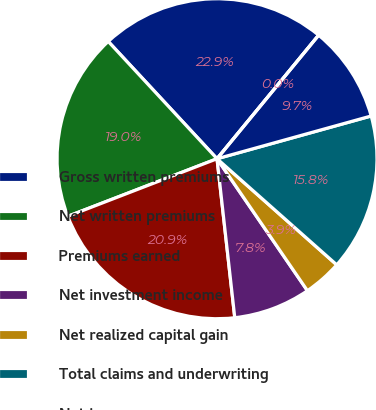Convert chart to OTSL. <chart><loc_0><loc_0><loc_500><loc_500><pie_chart><fcel>Gross written premiums<fcel>Net written premiums<fcel>Premiums earned<fcel>Net investment income<fcel>Net realized capital gain<fcel>Total claims and underwriting<fcel>Net income<fcel>Net income per common share -<nl><fcel>22.86%<fcel>18.96%<fcel>20.91%<fcel>7.79%<fcel>3.9%<fcel>15.85%<fcel>9.74%<fcel>0.0%<nl></chart> 